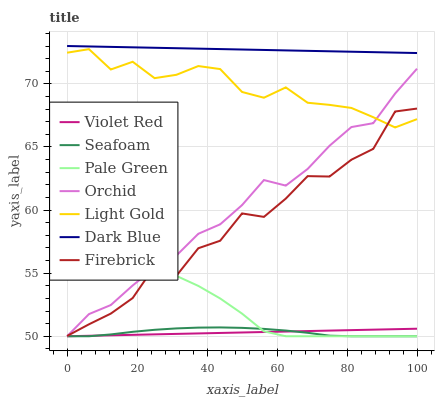Does Violet Red have the minimum area under the curve?
Answer yes or no. Yes. Does Dark Blue have the maximum area under the curve?
Answer yes or no. Yes. Does Firebrick have the minimum area under the curve?
Answer yes or no. No. Does Firebrick have the maximum area under the curve?
Answer yes or no. No. Is Dark Blue the smoothest?
Answer yes or no. Yes. Is Firebrick the roughest?
Answer yes or no. Yes. Is Seafoam the smoothest?
Answer yes or no. No. Is Seafoam the roughest?
Answer yes or no. No. Does Violet Red have the lowest value?
Answer yes or no. Yes. Does Firebrick have the lowest value?
Answer yes or no. No. Does Dark Blue have the highest value?
Answer yes or no. Yes. Does Firebrick have the highest value?
Answer yes or no. No. Is Seafoam less than Light Gold?
Answer yes or no. Yes. Is Dark Blue greater than Violet Red?
Answer yes or no. Yes. Does Orchid intersect Firebrick?
Answer yes or no. Yes. Is Orchid less than Firebrick?
Answer yes or no. No. Is Orchid greater than Firebrick?
Answer yes or no. No. Does Seafoam intersect Light Gold?
Answer yes or no. No. 